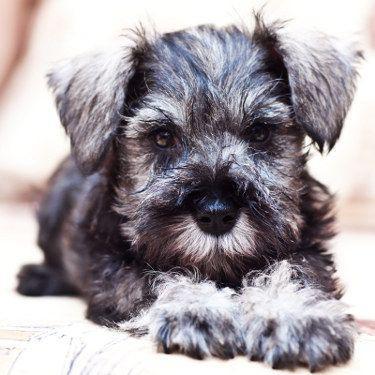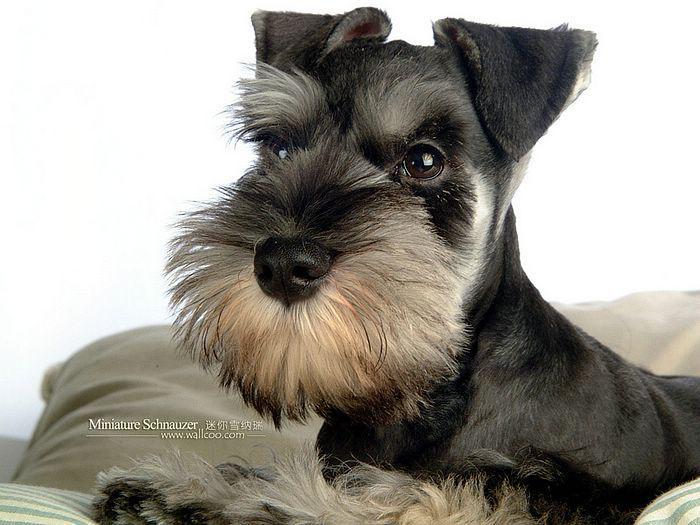The first image is the image on the left, the second image is the image on the right. Evaluate the accuracy of this statement regarding the images: "There is at least one dog with a blackish/bluish colouring.". Is it true? Answer yes or no. Yes. 